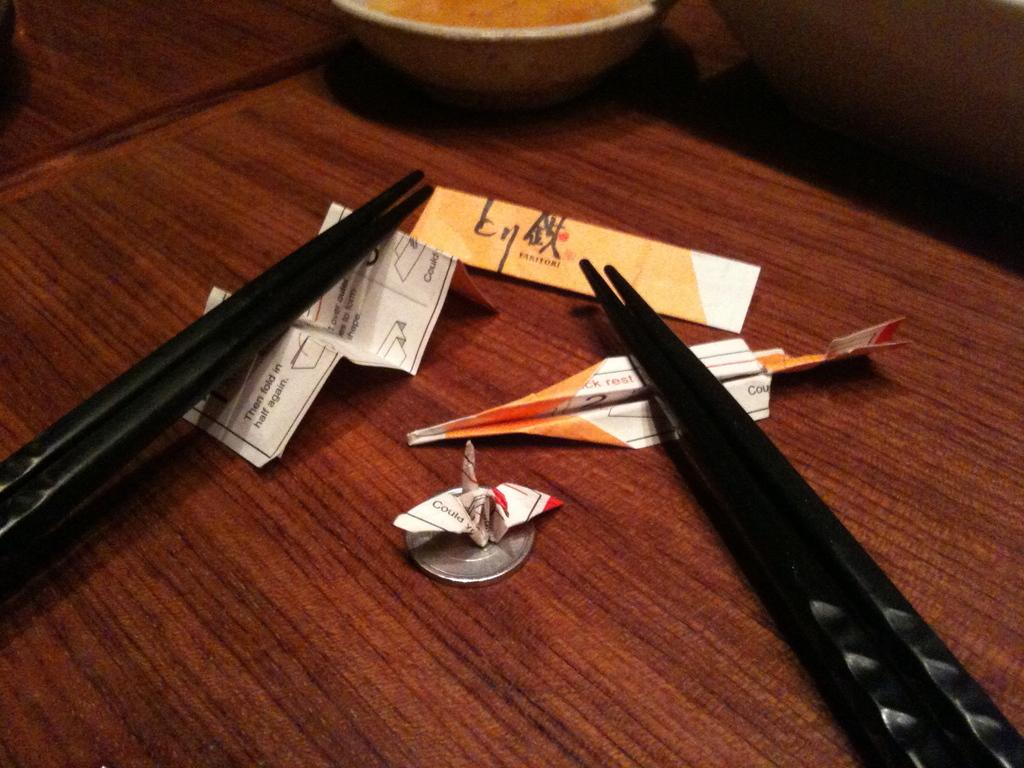How many sticks can be seen in the image? There are four sticks in the image. What other objects are present in the image besides the sticks? There is a paper and a bowl in the image. Where are all of these objects located? All of these objects are on a table. What thrilling idea is being discussed in the image? There is no indication of a discussion or an idea in the image, as it only shows four sticks, a paper, and a bowl on a table. 